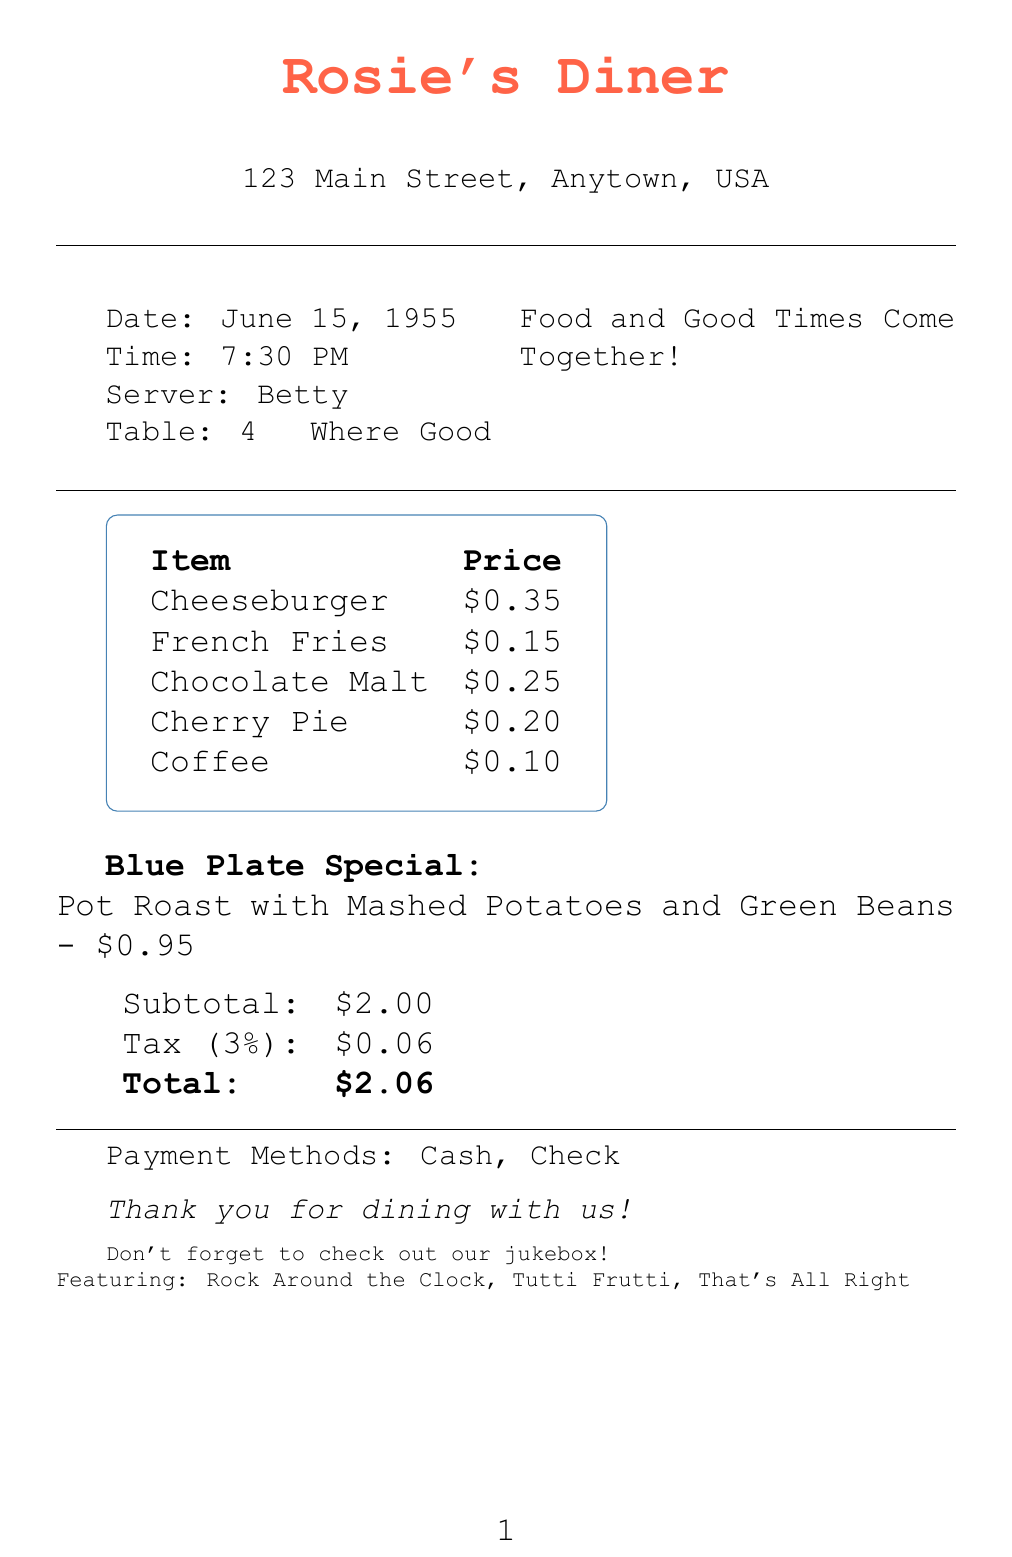What is the name of the diner? The name of the diner is listed at the top of the document as Rosie's Diner.
Answer: Rosie's Diner What time was the meal served? The time of the meal is provided in the document as 7:30 PM.
Answer: 7:30 PM Who was the server? The server's name is indicated in the document as Betty.
Answer: Betty What is the price of the Cheeseburger? The price of the Cheeseburger can be found in the menu items section, which lists it as $0.35.
Answer: $0.35 What is the total amount paid? The total amount is calculated in the document, shown as $2.06.
Answer: $2.06 What type of special was offered? The document describes a Blue Plate Special, which is Pot Roast with Mashed Potatoes and Green Beans.
Answer: Blue Plate Special: Pot Roast with Mashed Potatoes and Green Beans How much tax was charged? The tax amount is stated in the document as $0.06.
Answer: $0.06 What are two payment methods available? The document lists Cash and Check as the available payment methods.
Answer: Cash, Check What is the diner’s slogan? The diner’s slogan is presented in the document as "Where Good Food and Good Times Come Together!"
Answer: Where Good Food and Good Times Come Together! 